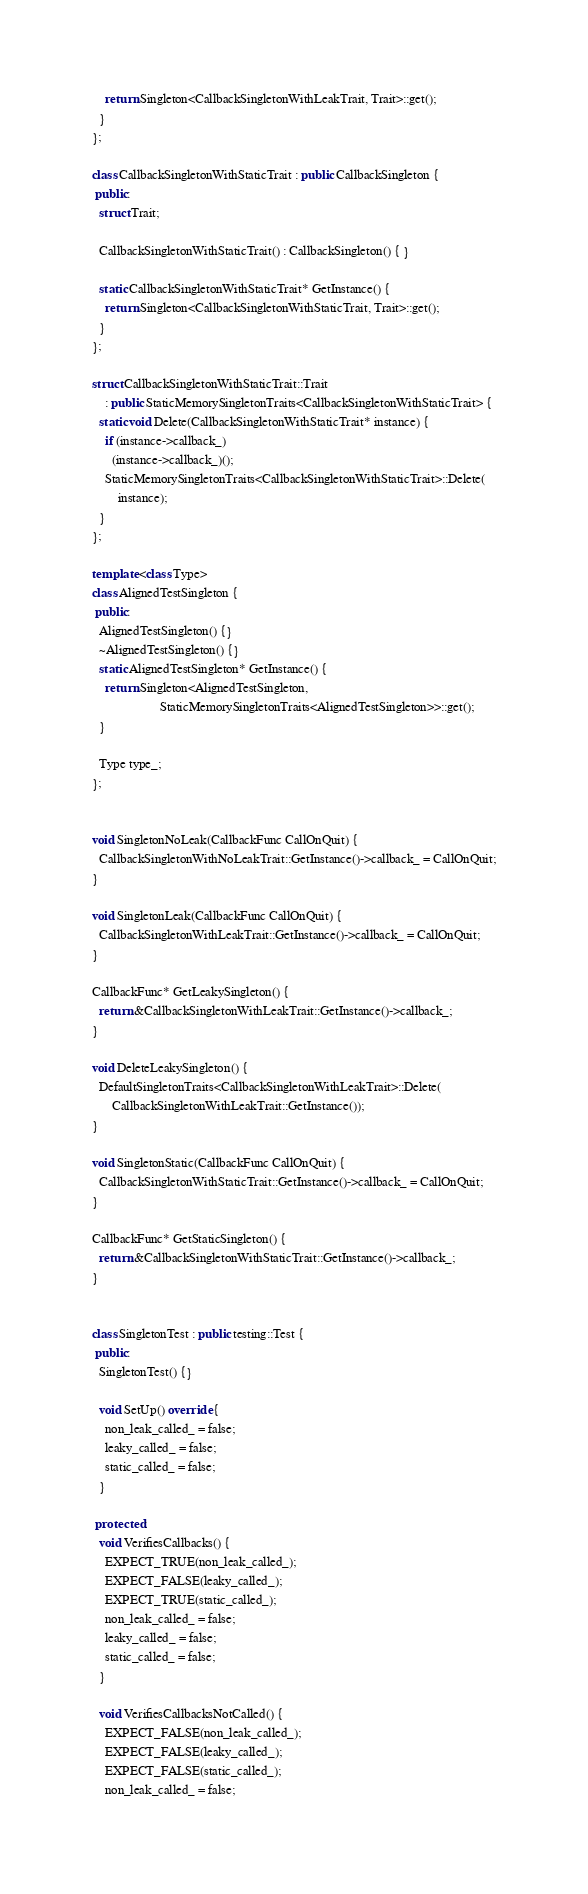Convert code to text. <code><loc_0><loc_0><loc_500><loc_500><_C++_>    return Singleton<CallbackSingletonWithLeakTrait, Trait>::get();
  }
};

class CallbackSingletonWithStaticTrait : public CallbackSingleton {
 public:
  struct Trait;

  CallbackSingletonWithStaticTrait() : CallbackSingleton() { }

  static CallbackSingletonWithStaticTrait* GetInstance() {
    return Singleton<CallbackSingletonWithStaticTrait, Trait>::get();
  }
};

struct CallbackSingletonWithStaticTrait::Trait
    : public StaticMemorySingletonTraits<CallbackSingletonWithStaticTrait> {
  static void Delete(CallbackSingletonWithStaticTrait* instance) {
    if (instance->callback_)
      (instance->callback_)();
    StaticMemorySingletonTraits<CallbackSingletonWithStaticTrait>::Delete(
        instance);
  }
};

template <class Type>
class AlignedTestSingleton {
 public:
  AlignedTestSingleton() {}
  ~AlignedTestSingleton() {}
  static AlignedTestSingleton* GetInstance() {
    return Singleton<AlignedTestSingleton,
                     StaticMemorySingletonTraits<AlignedTestSingleton>>::get();
  }

  Type type_;
};


void SingletonNoLeak(CallbackFunc CallOnQuit) {
  CallbackSingletonWithNoLeakTrait::GetInstance()->callback_ = CallOnQuit;
}

void SingletonLeak(CallbackFunc CallOnQuit) {
  CallbackSingletonWithLeakTrait::GetInstance()->callback_ = CallOnQuit;
}

CallbackFunc* GetLeakySingleton() {
  return &CallbackSingletonWithLeakTrait::GetInstance()->callback_;
}

void DeleteLeakySingleton() {
  DefaultSingletonTraits<CallbackSingletonWithLeakTrait>::Delete(
      CallbackSingletonWithLeakTrait::GetInstance());
}

void SingletonStatic(CallbackFunc CallOnQuit) {
  CallbackSingletonWithStaticTrait::GetInstance()->callback_ = CallOnQuit;
}

CallbackFunc* GetStaticSingleton() {
  return &CallbackSingletonWithStaticTrait::GetInstance()->callback_;
}


class SingletonTest : public testing::Test {
 public:
  SingletonTest() {}

  void SetUp() override {
    non_leak_called_ = false;
    leaky_called_ = false;
    static_called_ = false;
  }

 protected:
  void VerifiesCallbacks() {
    EXPECT_TRUE(non_leak_called_);
    EXPECT_FALSE(leaky_called_);
    EXPECT_TRUE(static_called_);
    non_leak_called_ = false;
    leaky_called_ = false;
    static_called_ = false;
  }

  void VerifiesCallbacksNotCalled() {
    EXPECT_FALSE(non_leak_called_);
    EXPECT_FALSE(leaky_called_);
    EXPECT_FALSE(static_called_);
    non_leak_called_ = false;</code> 